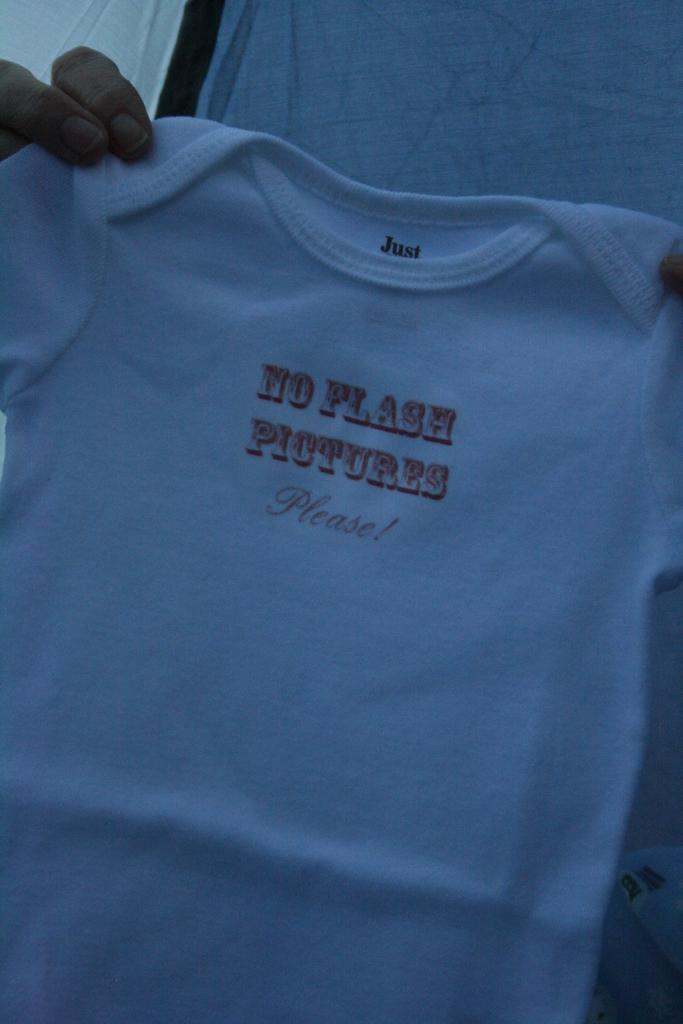Provide a one-sentence caption for the provided image. Someone holds baby clothing that says, "No Flash Pictures Please". 